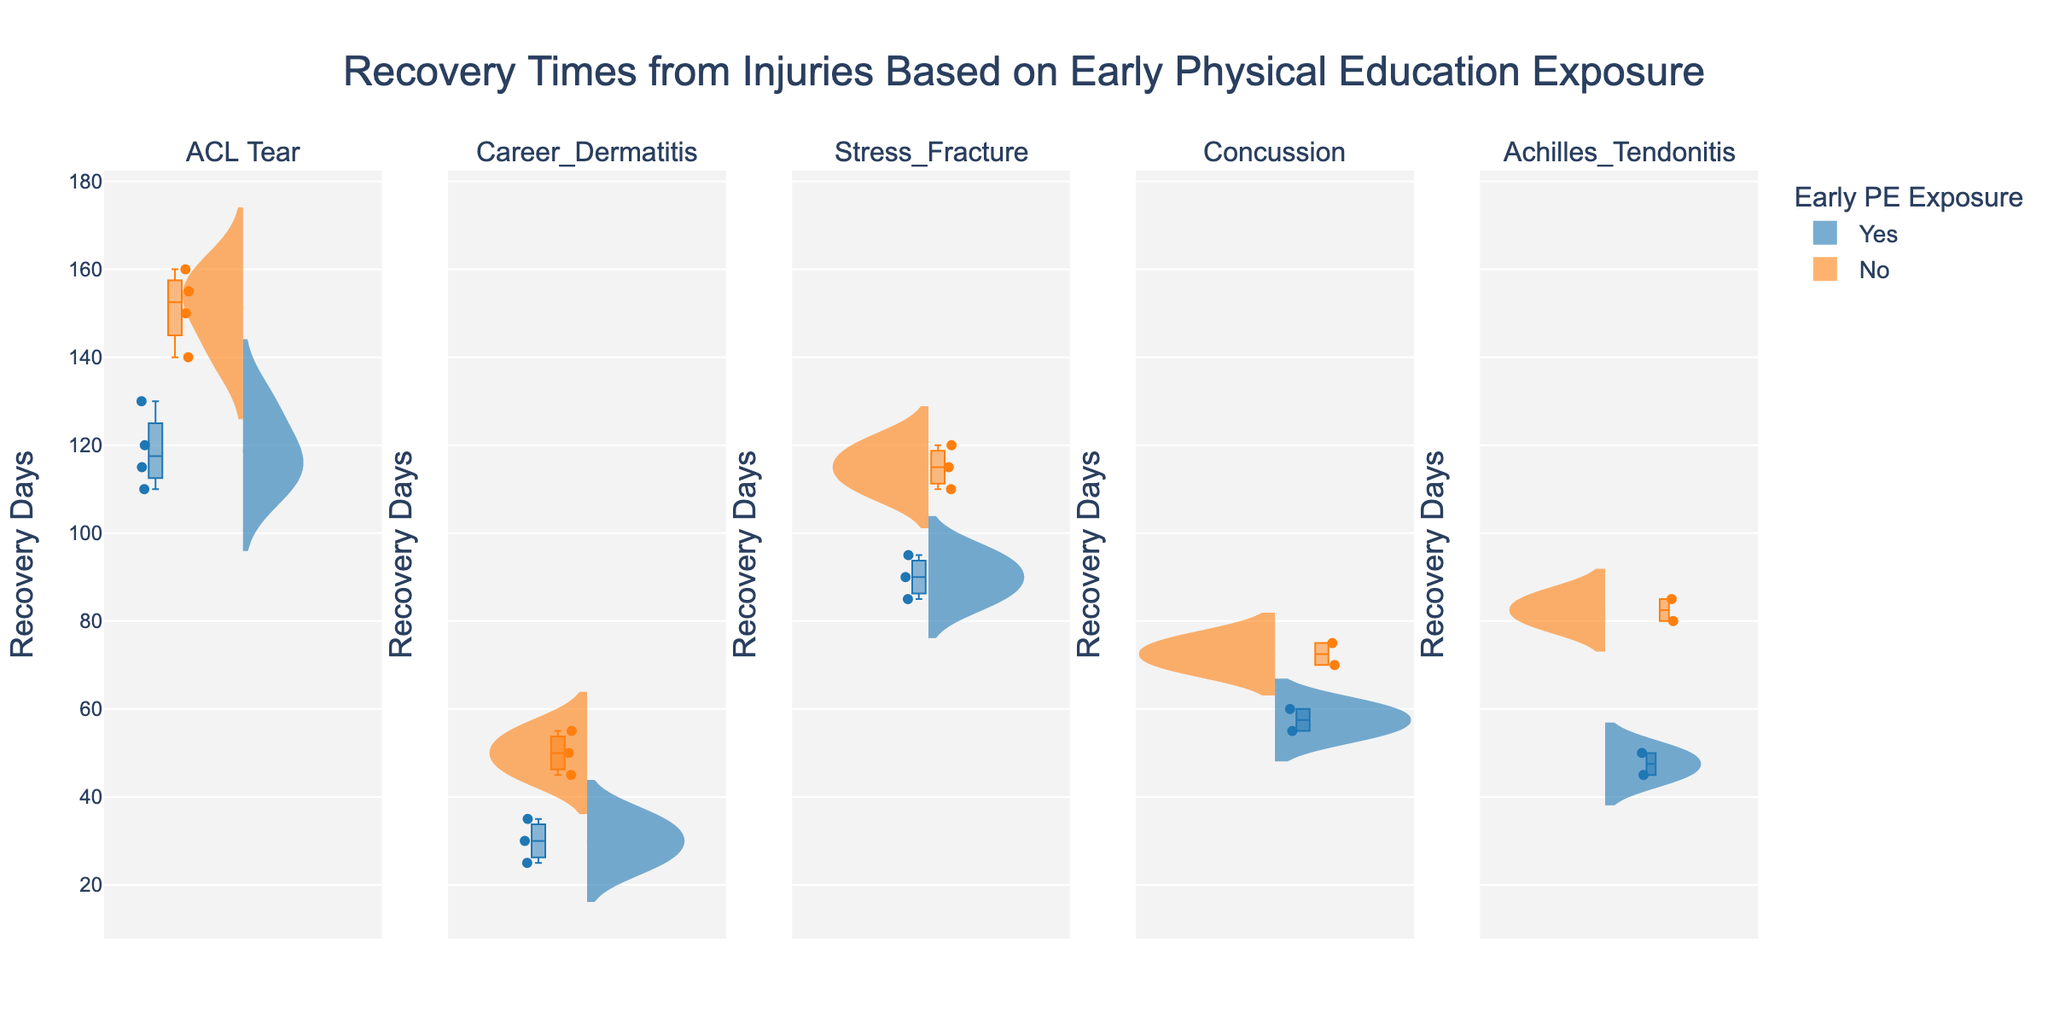what is the title of the chart? The title is located at the top of the figure and indicates the main subject. The title is "Recovery Times from Injuries Based on Early Physical Education Exposure."
Answer: Recovery Times from Injuries Based on Early Physical Education Exposure how many injury types are presented in this chart? To find the number of injury types, count the separate subplot titles. There are six injury types shown: ACL Tear, Career Dermatitis, Stress Fracture, Concussion, and Achilles Tendonitis.
Answer: 5 what is the median recovery time for stress fractures with early PE exposure? In the violin chart overlay for stress fractures, the box plot indicates the median recovery time. For those with early PE exposure (in blue), the median is at the center of the box plot's horizontal line. The median is approximately 90 days.
Answer: 90 days which injury type shows the greatest difference in recovery time between those with and without early PE exposure? Compare the distances between the median lines in the box plots of each injury type. For Achilles Tendonitis, the difference is the greatest, with those without early PE exposure taking much longer.
Answer: Achilles Tendonitis what is the range of recovery times for concussions without early PE exposure? For concussions without early PE exposure (orange), the range is the difference between the maximum and minimum values in the box plot. The box plot shows the maximum is about 75 days and the minimum is about 70 days, so the range is 5 days.
Answer: 5 days are there any injury types where the median recovery time is lower for those without early PE exposure? By examining the medians in the box plots, none of the injury types have a lower median recovery time for those without early PE exposure compared to those with early PE exposure.
Answer: No which injury has the smallest interquartile range (IQR) for individuals with early PE exposure? The IQR is the distance between the first and third quartiles in the box plot. For those with early PE exposure (blue boxes), Career Dermatitis shows the smallest IQR, as the box is the narrowest.
Answer: Career Dermatitis what is the average recovery time for ACL tear injuries without early PE exposure? To calculate the average, sum the recovery days for the four data points (150 + 140 + 160 + 155) which equals 605. Then divide this sum by the number of data points, 4. The average recovery time is 605 / 4 = 151.25 days.
Answer: 151.25 days 